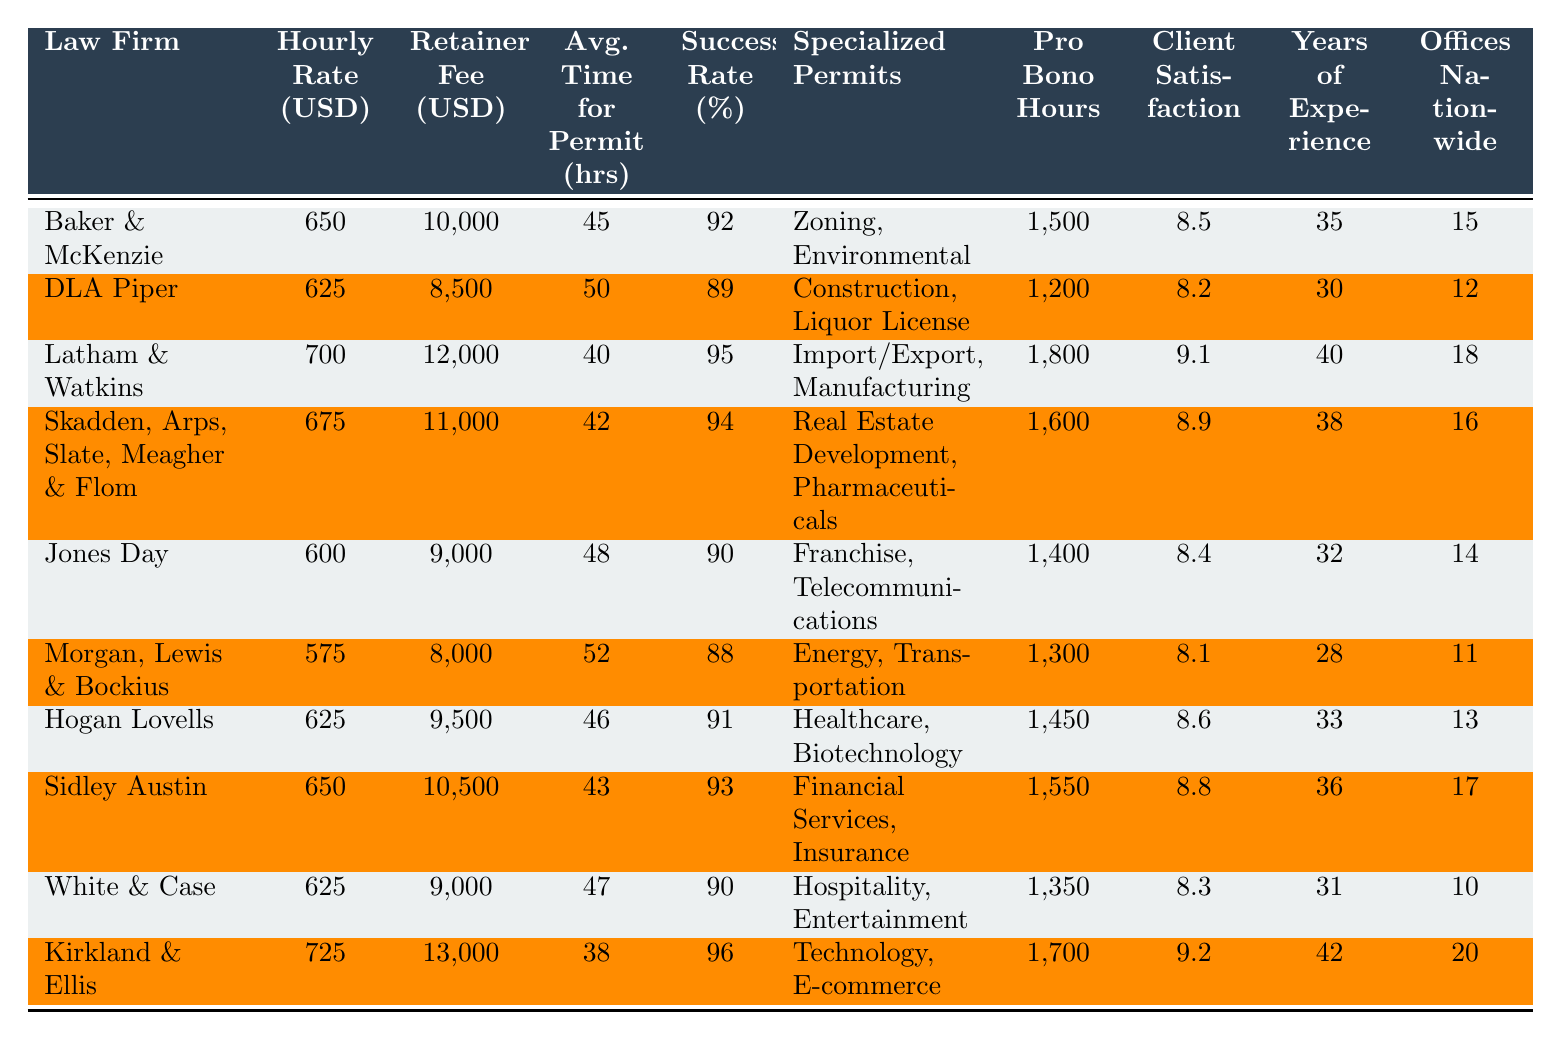What is the hourly rate of the most expensive law firm? The law firm with the highest hourly rate can be found by scanning the "Hourly Rate (USD)" column. Kirkland & Ellis has the highest rate listed at 725 USD.
Answer: 725 Which law firm has the lowest retainer fee? To find the lowest retainer fee, check the "Retainer Fee (USD)" column for the smallest number. Morgan, Lewis & Bockius has the lowest retainer fee at 8000 USD.
Answer: 8000 What is the average client satisfaction rating for all law firms? To calculate the average, sum all the client satisfaction ratings (8.5 + 8.2 + 9.1 + 8.9 + 8.4 + 8.1 + 8.6 + 8.8 + 8.3 + 9.2) = 88.1, then divide by the number of firms (10), resulting in 88.1 / 10 = 8.81.
Answer: 8.81 Is there a direct relationship between retainer fee and success rate for the firms? This question requires examining both columns for any patterns. While some firms with higher retainer fees have high success rates, the relationship is not consistent across all firms, indicating no direct correlation.
Answer: No Which law firm has the highest success rate and how much do they charge per hour? First, identify the highest success rate by looking at the "Success Rate (%)" column where Kirkland & Ellis has the highest rate at 96%. Then check the corresponding "Hourly Rate (USD)" which is 725 USD.
Answer: 725 What is the total number of pro bono hours across all firms? To find the total, sum the pro bono hours for each law firm (1500 + 1200 + 1800 + 1600 + 1400 + 1300 + 1450 + 1550 + 1350 + 1700) = 15000 hours.
Answer: 15000 Which law firm has the highest years of experience in permit law? To find the maximum, look at the "Years of Experience in Permit Law" column. Kirkland & Ellis has the highest experience listed at 42 years.
Answer: 42 What is the average hourly rate of firms that specialize in Technology and E-commerce? Only Kirkland & Ellis specializes in Technology and E-commerce, with an hourly rate of 725 USD. Therefore, the average is simply 725 USD since there's only one firm.
Answer: 725 Identify the firm with the longest average time for permit processing and provide that time. The longest time for permit processing among the firms can be examined in the "Avg. Time for Permit Process (hours)" column. Morgan, Lewis & Bockius has an average of 52 hours.
Answer: 52 Do any law firms have the same hourly rate? By comparing the "Hourly Rate (USD)" column, Baker & McKenzie and Sidley Austin both charge 650 USD per hour.
Answer: Yes What is the difference in retainer fees between the firm with the highest and lowest fee? The highest retainer fee is charged by Kirkland & Ellis at 13000 USD, and the lowest is Morgan, Lewis & Bockius at 8000 USD. The difference is 13000 - 8000 = 5000 USD.
Answer: 5000 